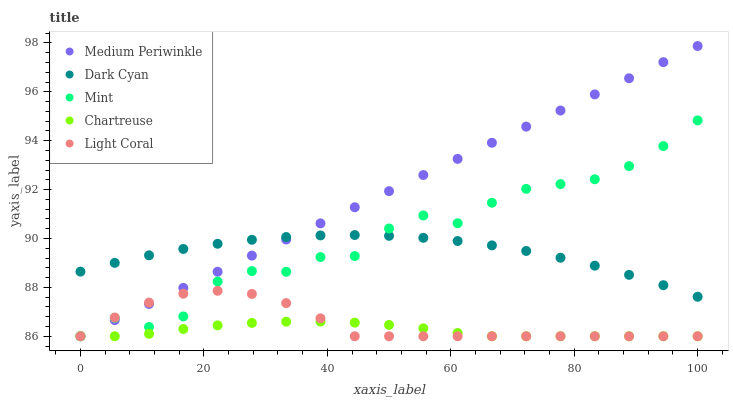Does Chartreuse have the minimum area under the curve?
Answer yes or no. Yes. Does Medium Periwinkle have the maximum area under the curve?
Answer yes or no. Yes. Does Mint have the minimum area under the curve?
Answer yes or no. No. Does Mint have the maximum area under the curve?
Answer yes or no. No. Is Medium Periwinkle the smoothest?
Answer yes or no. Yes. Is Mint the roughest?
Answer yes or no. Yes. Is Chartreuse the smoothest?
Answer yes or no. No. Is Chartreuse the roughest?
Answer yes or no. No. Does Mint have the lowest value?
Answer yes or no. Yes. Does Medium Periwinkle have the highest value?
Answer yes or no. Yes. Does Mint have the highest value?
Answer yes or no. No. Is Chartreuse less than Dark Cyan?
Answer yes or no. Yes. Is Dark Cyan greater than Light Coral?
Answer yes or no. Yes. Does Dark Cyan intersect Medium Periwinkle?
Answer yes or no. Yes. Is Dark Cyan less than Medium Periwinkle?
Answer yes or no. No. Is Dark Cyan greater than Medium Periwinkle?
Answer yes or no. No. Does Chartreuse intersect Dark Cyan?
Answer yes or no. No. 